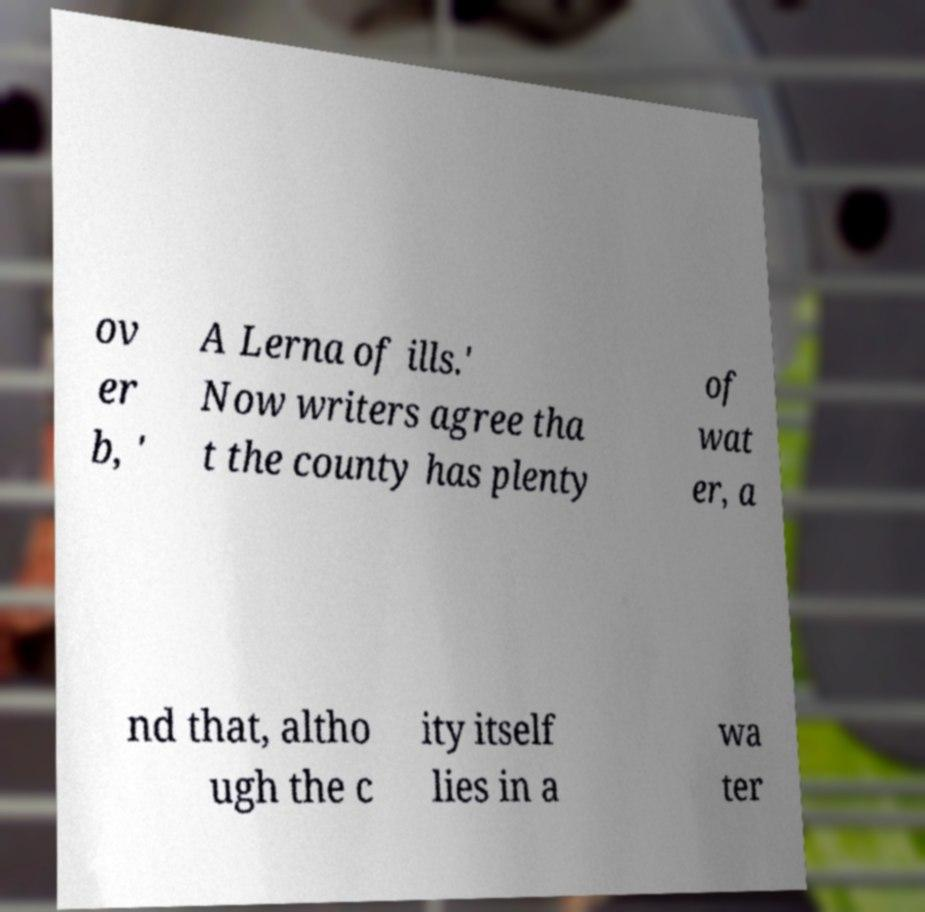Can you read and provide the text displayed in the image?This photo seems to have some interesting text. Can you extract and type it out for me? ov er b, ' A Lerna of ills.' Now writers agree tha t the county has plenty of wat er, a nd that, altho ugh the c ity itself lies in a wa ter 